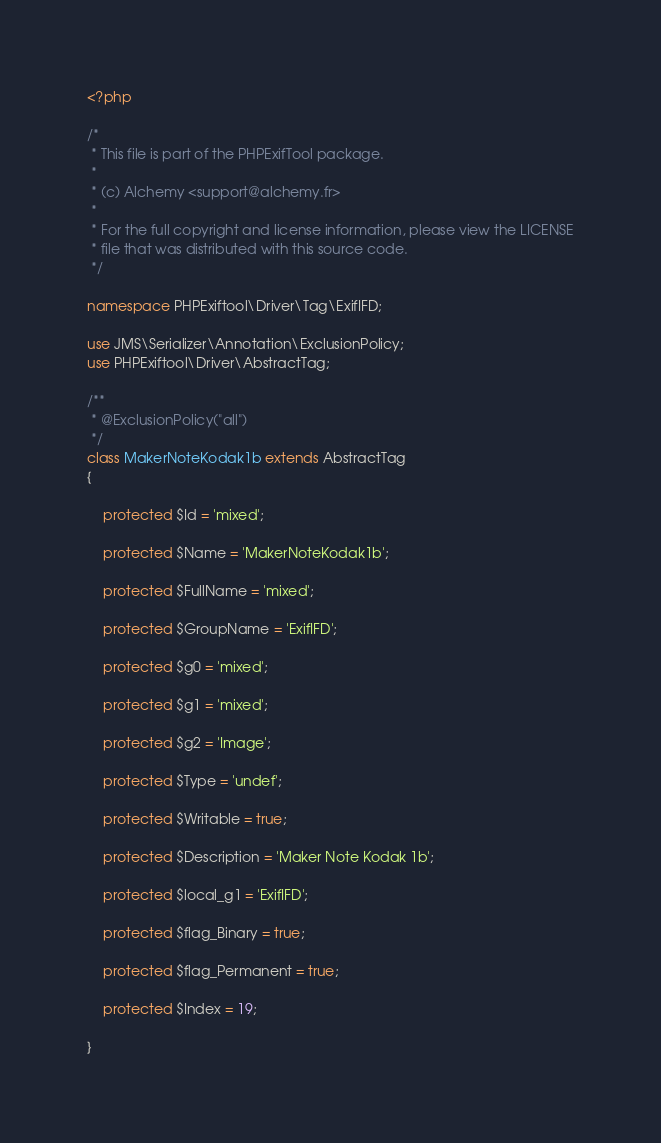<code> <loc_0><loc_0><loc_500><loc_500><_PHP_><?php

/*
 * This file is part of the PHPExifTool package.
 *
 * (c) Alchemy <support@alchemy.fr>
 *
 * For the full copyright and license information, please view the LICENSE
 * file that was distributed with this source code.
 */

namespace PHPExiftool\Driver\Tag\ExifIFD;

use JMS\Serializer\Annotation\ExclusionPolicy;
use PHPExiftool\Driver\AbstractTag;

/**
 * @ExclusionPolicy("all")
 */
class MakerNoteKodak1b extends AbstractTag
{

    protected $Id = 'mixed';

    protected $Name = 'MakerNoteKodak1b';

    protected $FullName = 'mixed';

    protected $GroupName = 'ExifIFD';

    protected $g0 = 'mixed';

    protected $g1 = 'mixed';

    protected $g2 = 'Image';

    protected $Type = 'undef';

    protected $Writable = true;

    protected $Description = 'Maker Note Kodak 1b';

    protected $local_g1 = 'ExifIFD';

    protected $flag_Binary = true;

    protected $flag_Permanent = true;

    protected $Index = 19;

}
</code> 